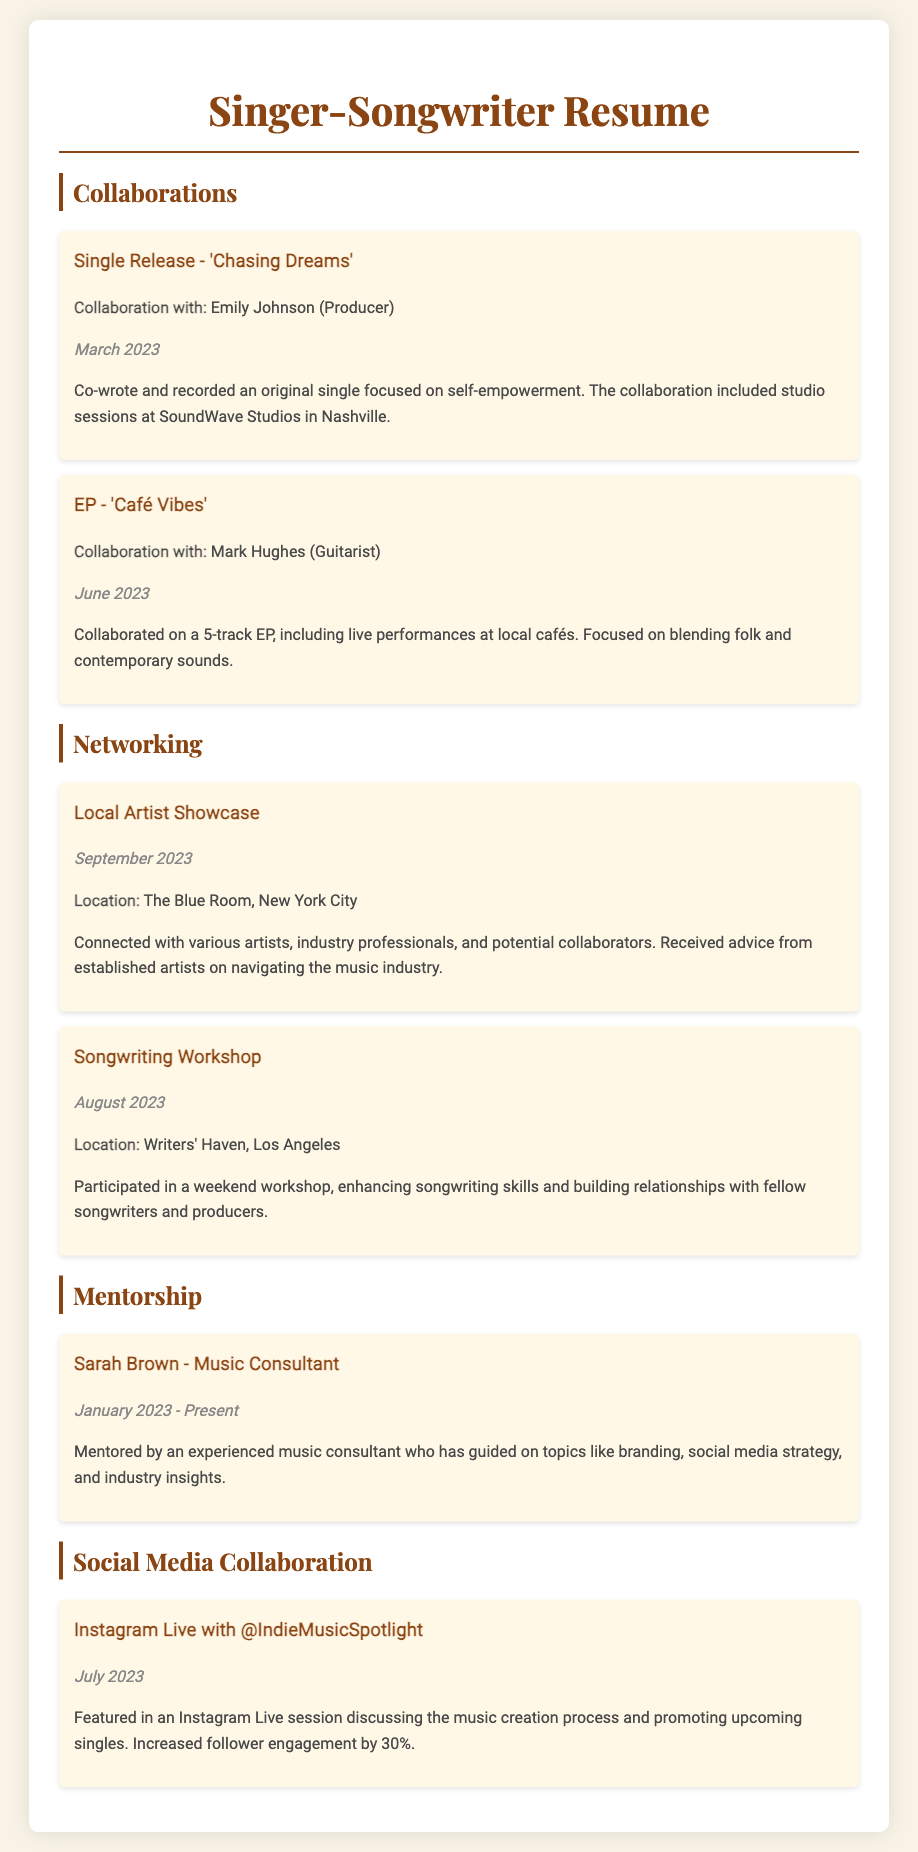What is the title of the single released in March 2023? The title of the single released in March 2023 is 'Chasing Dreams'.
Answer: 'Chasing Dreams' Who collaborated with you on the EP 'Café Vibes'? The collaboration on the EP 'Café Vibes' was with Mark Hughes (Guitarist).
Answer: Mark Hughes (Guitarist) What was the location of the Local Artist Showcase? The location of the Local Artist Showcase was The Blue Room, New York City.
Answer: The Blue Room, New York City When did you participate in the Songwriting Workshop? The Songwriting Workshop took place in August 2023.
Answer: August 2023 Who is your mentor? Your mentor is Sarah Brown (Music Consultant).
Answer: Sarah Brown - Music Consultant What increased follower engagement by 30%? The Instagram Live session with @IndieMusicSpotlight increased follower engagement by 30%.
Answer: Instagram Live with @IndieMusicSpotlight What is one topic you received guidance on from your mentor? One topic you received guidance on from your mentor was branding.
Answer: Branding How many tracks are included in the EP 'Café Vibes'? The EP 'Café Vibes' includes 5 tracks.
Answer: 5 tracks What genre combination was focused on in the EP? The genre combination focused on in the EP was folk and contemporary sounds.
Answer: Folk and contemporary 